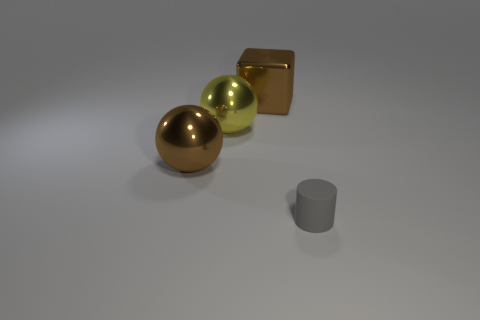Add 4 gray rubber objects. How many objects exist? 8 Subtract all cylinders. How many objects are left? 3 Subtract all tiny purple shiny balls. Subtract all balls. How many objects are left? 2 Add 2 gray matte objects. How many gray matte objects are left? 3 Add 1 green metal cylinders. How many green metal cylinders exist? 1 Subtract 0 purple cylinders. How many objects are left? 4 